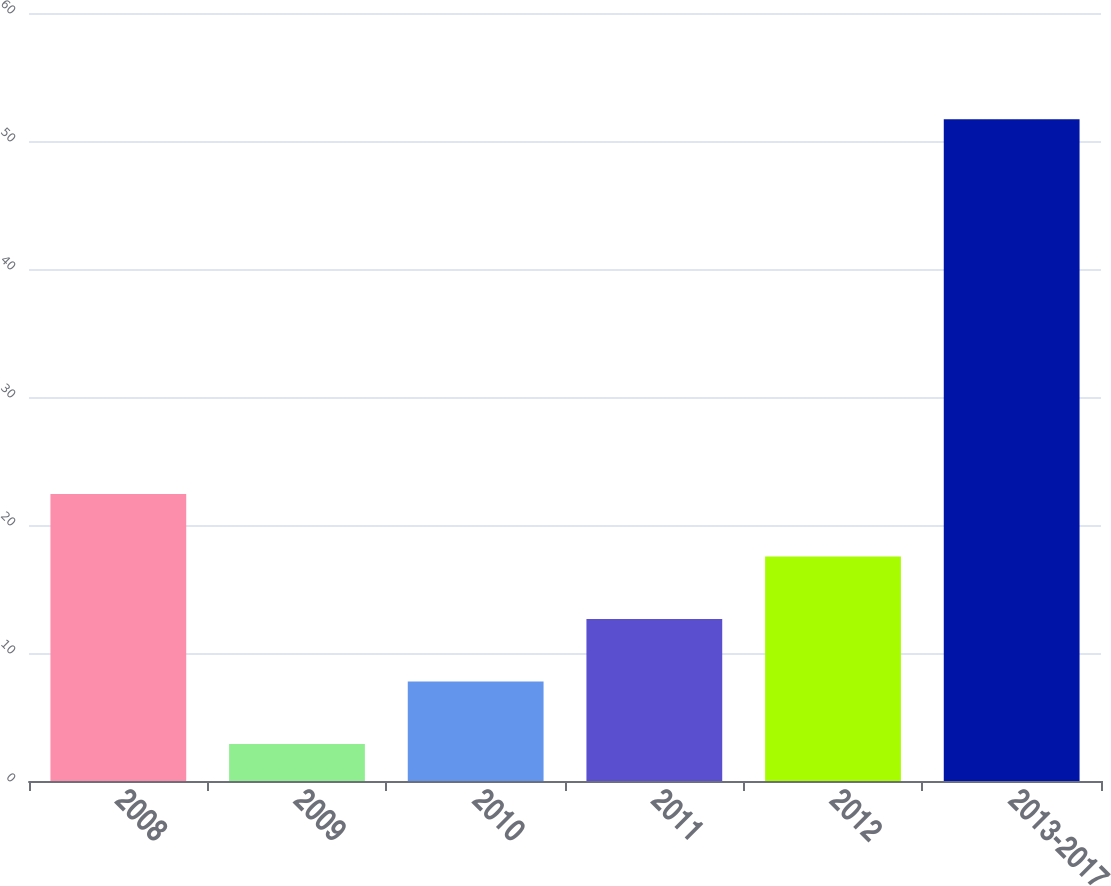<chart> <loc_0><loc_0><loc_500><loc_500><bar_chart><fcel>2008<fcel>2009<fcel>2010<fcel>2011<fcel>2012<fcel>2013-2017<nl><fcel>22.42<fcel>2.9<fcel>7.78<fcel>12.66<fcel>17.54<fcel>51.7<nl></chart> 